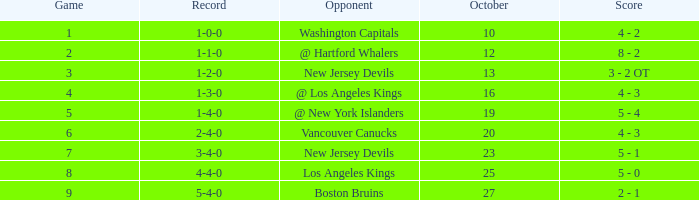Which game has the highest score in October with 9? 27.0. 